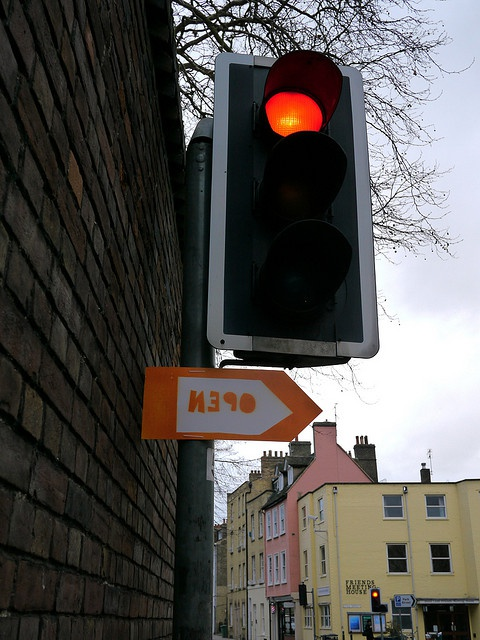Describe the objects in this image and their specific colors. I can see traffic light in black, gray, and red tones, traffic light in black, gray, red, and yellow tones, and traffic light in black and gray tones in this image. 